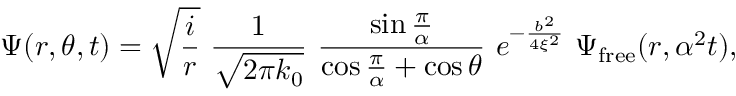Convert formula to latex. <formula><loc_0><loc_0><loc_500><loc_500>\Psi ( r , \theta , t ) = \sqrt { { \frac { i } { r } } } \, { \frac { 1 } { \sqrt { 2 \pi k _ { 0 } } } } \, { \frac { \sin { \frac { \pi } { \alpha } } } { \cos { \frac { \pi } { \alpha } } + \cos \theta } } \, e ^ { - { \frac { b ^ { 2 } } { 4 \xi ^ { 2 } } } } \, \Psi _ { f r e e } ( r , \alpha ^ { 2 } t ) ,</formula> 